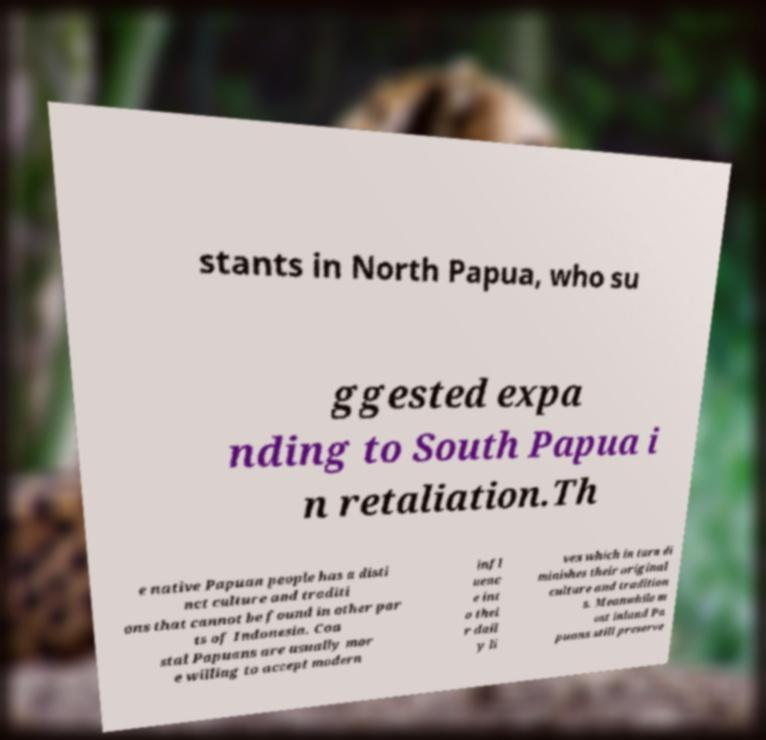There's text embedded in this image that I need extracted. Can you transcribe it verbatim? stants in North Papua, who su ggested expa nding to South Papua i n retaliation.Th e native Papuan people has a disti nct culture and traditi ons that cannot be found in other par ts of Indonesia. Coa stal Papuans are usually mor e willing to accept modern infl uenc e int o thei r dail y li ves which in turn di minishes their original culture and tradition s. Meanwhile m ost inland Pa puans still preserve 